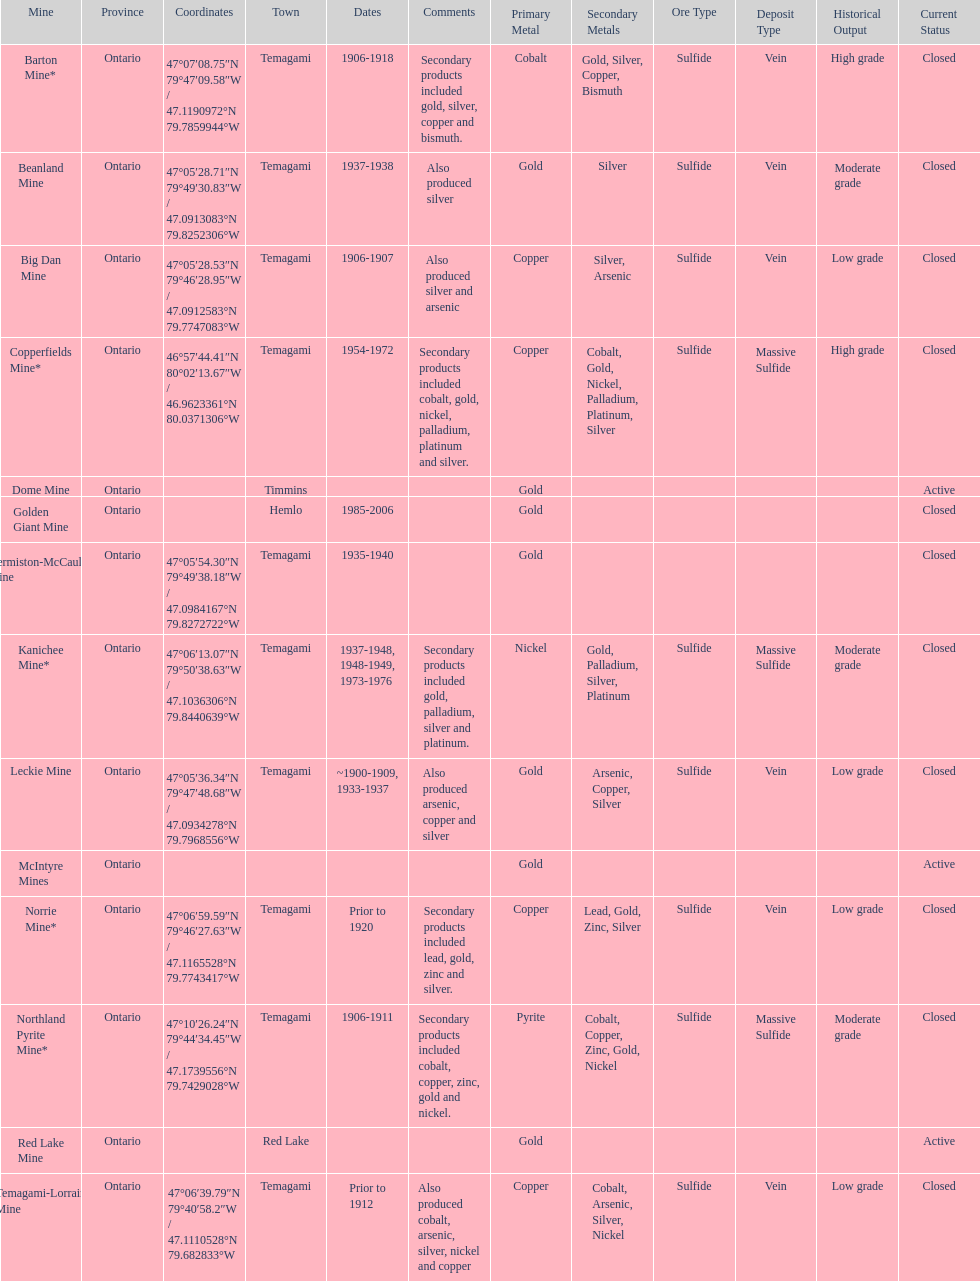Parse the full table. {'header': ['Mine', 'Province', 'Coordinates', 'Town', 'Dates', 'Comments', 'Primary Metal', 'Secondary Metals', 'Ore Type', 'Deposit Type', 'Historical Output', 'Current Status'], 'rows': [['Barton Mine*', 'Ontario', '47°07′08.75″N 79°47′09.58″W\ufeff / \ufeff47.1190972°N 79.7859944°W', 'Temagami', '1906-1918', 'Secondary products included gold, silver, copper and bismuth.', 'Cobalt', 'Gold, Silver, Copper, Bismuth', 'Sulfide', 'Vein', 'High grade', 'Closed'], ['Beanland Mine', 'Ontario', '47°05′28.71″N 79°49′30.83″W\ufeff / \ufeff47.0913083°N 79.8252306°W', 'Temagami', '1937-1938', 'Also produced silver', 'Gold', 'Silver', 'Sulfide', 'Vein', 'Moderate grade', 'Closed'], ['Big Dan Mine', 'Ontario', '47°05′28.53″N 79°46′28.95″W\ufeff / \ufeff47.0912583°N 79.7747083°W', 'Temagami', '1906-1907', 'Also produced silver and arsenic', 'Copper', 'Silver, Arsenic', 'Sulfide', 'Vein', 'Low grade', 'Closed'], ['Copperfields Mine*', 'Ontario', '46°57′44.41″N 80°02′13.67″W\ufeff / \ufeff46.9623361°N 80.0371306°W', 'Temagami', '1954-1972', 'Secondary products included cobalt, gold, nickel, palladium, platinum and silver.', 'Copper', 'Cobalt, Gold, Nickel, Palladium, Platinum, Silver', 'Sulfide', 'Massive Sulfide', 'High grade', 'Closed'], ['Dome Mine', 'Ontario', '', 'Timmins', '', '', 'Gold', '', '', '', '', 'Active'], ['Golden Giant Mine', 'Ontario', '', 'Hemlo', '1985-2006', '', 'Gold', '', '', '', '', 'Closed'], ['Hermiston-McCauley Mine', 'Ontario', '47°05′54.30″N 79°49′38.18″W\ufeff / \ufeff47.0984167°N 79.8272722°W', 'Temagami', '1935-1940', '', 'Gold', '', '', '', '', 'Closed'], ['Kanichee Mine*', 'Ontario', '47°06′13.07″N 79°50′38.63″W\ufeff / \ufeff47.1036306°N 79.8440639°W', 'Temagami', '1937-1948, 1948-1949, 1973-1976', 'Secondary products included gold, palladium, silver and platinum.', 'Nickel', 'Gold, Palladium, Silver, Platinum', 'Sulfide', 'Massive Sulfide', 'Moderate grade', 'Closed'], ['Leckie Mine', 'Ontario', '47°05′36.34″N 79°47′48.68″W\ufeff / \ufeff47.0934278°N 79.7968556°W', 'Temagami', '~1900-1909, 1933-1937', 'Also produced arsenic, copper and silver', 'Gold', 'Arsenic, Copper, Silver', 'Sulfide', 'Vein', 'Low grade', 'Closed'], ['McIntyre Mines', 'Ontario', '', '', '', '', 'Gold', '', '', '', '', 'Active'], ['Norrie Mine*', 'Ontario', '47°06′59.59″N 79°46′27.63″W\ufeff / \ufeff47.1165528°N 79.7743417°W', 'Temagami', 'Prior to 1920', 'Secondary products included lead, gold, zinc and silver.', 'Copper', 'Lead, Gold, Zinc, Silver', 'Sulfide', 'Vein', 'Low grade', 'Closed'], ['Northland Pyrite Mine*', 'Ontario', '47°10′26.24″N 79°44′34.45″W\ufeff / \ufeff47.1739556°N 79.7429028°W', 'Temagami', '1906-1911', 'Secondary products included cobalt, copper, zinc, gold and nickel.', 'Pyrite', 'Cobalt, Copper, Zinc, Gold, Nickel', 'Sulfide', 'Massive Sulfide', 'Moderate grade', 'Closed'], ['Red Lake Mine', 'Ontario', '', 'Red Lake', '', '', 'Gold', '', '', '', '', 'Active'], ['Temagami-Lorrain Mine', 'Ontario', '47°06′39.79″N 79°40′58.2″W\ufeff / \ufeff47.1110528°N 79.682833°W', 'Temagami', 'Prior to 1912', 'Also produced cobalt, arsenic, silver, nickel and copper', 'Copper', 'Cobalt, Arsenic, Silver, Nickel', 'Sulfide', 'Vein', 'Low grade', 'Closed']]} What mine is in the town of timmins? Dome Mine. 